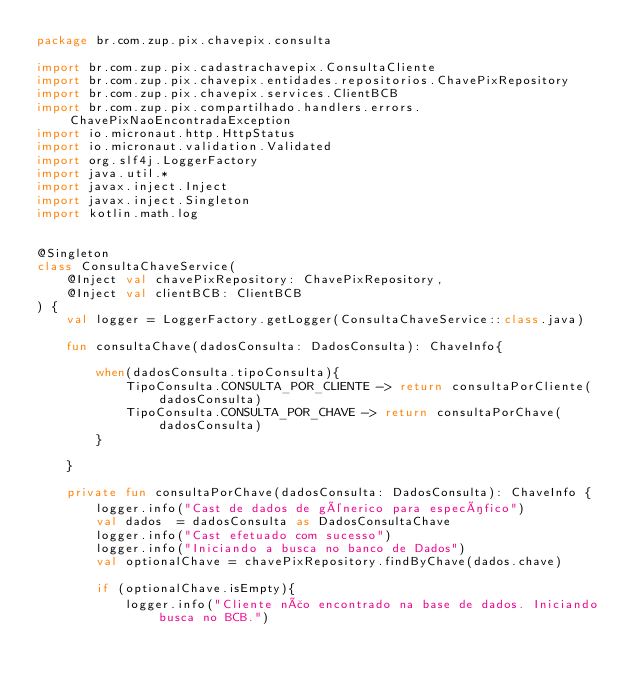Convert code to text. <code><loc_0><loc_0><loc_500><loc_500><_Kotlin_>package br.com.zup.pix.chavepix.consulta

import br.com.zup.pix.cadastrachavepix.ConsultaCliente
import br.com.zup.pix.chavepix.entidades.repositorios.ChavePixRepository
import br.com.zup.pix.chavepix.services.ClientBCB
import br.com.zup.pix.compartilhado.handlers.errors.ChavePixNaoEncontradaException
import io.micronaut.http.HttpStatus
import io.micronaut.validation.Validated
import org.slf4j.LoggerFactory
import java.util.*
import javax.inject.Inject
import javax.inject.Singleton
import kotlin.math.log


@Singleton
class ConsultaChaveService(
    @Inject val chavePixRepository: ChavePixRepository,
    @Inject val clientBCB: ClientBCB
) {
    val logger = LoggerFactory.getLogger(ConsultaChaveService::class.java)

    fun consultaChave(dadosConsulta: DadosConsulta): ChaveInfo{

        when(dadosConsulta.tipoConsulta){
            TipoConsulta.CONSULTA_POR_CLIENTE -> return consultaPorCliente(dadosConsulta)
            TipoConsulta.CONSULTA_POR_CHAVE -> return consultaPorChave(dadosConsulta)
        }

    }

    private fun consultaPorChave(dadosConsulta: DadosConsulta): ChaveInfo {
        logger.info("Cast de dados de génerico para específico")
        val dados  = dadosConsulta as DadosConsultaChave
        logger.info("Cast efetuado com sucesso")
        logger.info("Iniciando a busca no banco de Dados")
        val optionalChave = chavePixRepository.findByChave(dados.chave)

        if (optionalChave.isEmpty){
            logger.info("Cliente não encontrado na base de dados. Iniciando busca no BCB.")</code> 